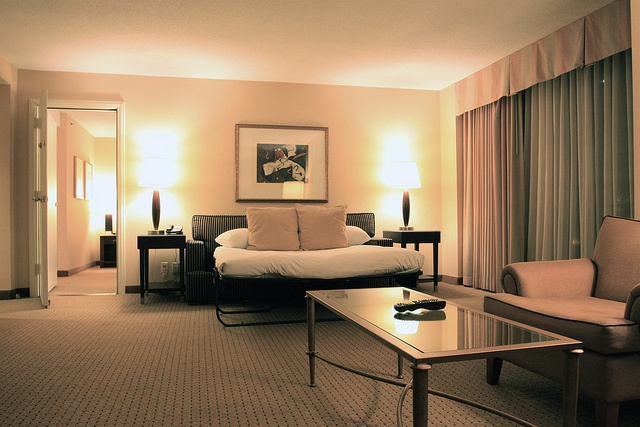Describe the objects in this image and their specific colors. I can see couch in olive, black, gray, salmon, and brown tones, chair in olive, black, gray, salmon, and brown tones, couch in olive, gray, and tan tones, bed in olive, gray, and tan tones, and couch in olive, black, and gray tones in this image. 